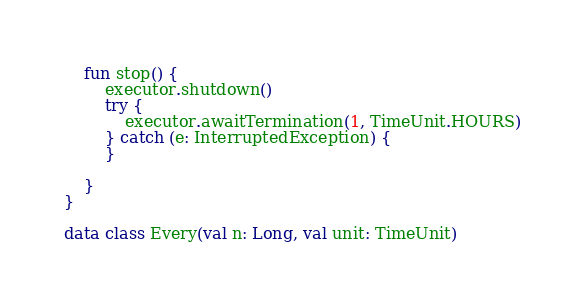Convert code to text. <code><loc_0><loc_0><loc_500><loc_500><_Kotlin_>    fun stop() {
        executor.shutdown()
        try {
            executor.awaitTermination(1, TimeUnit.HOURS)
        } catch (e: InterruptedException) {
        }

    }
}

data class Every(val n: Long, val unit: TimeUnit)</code> 